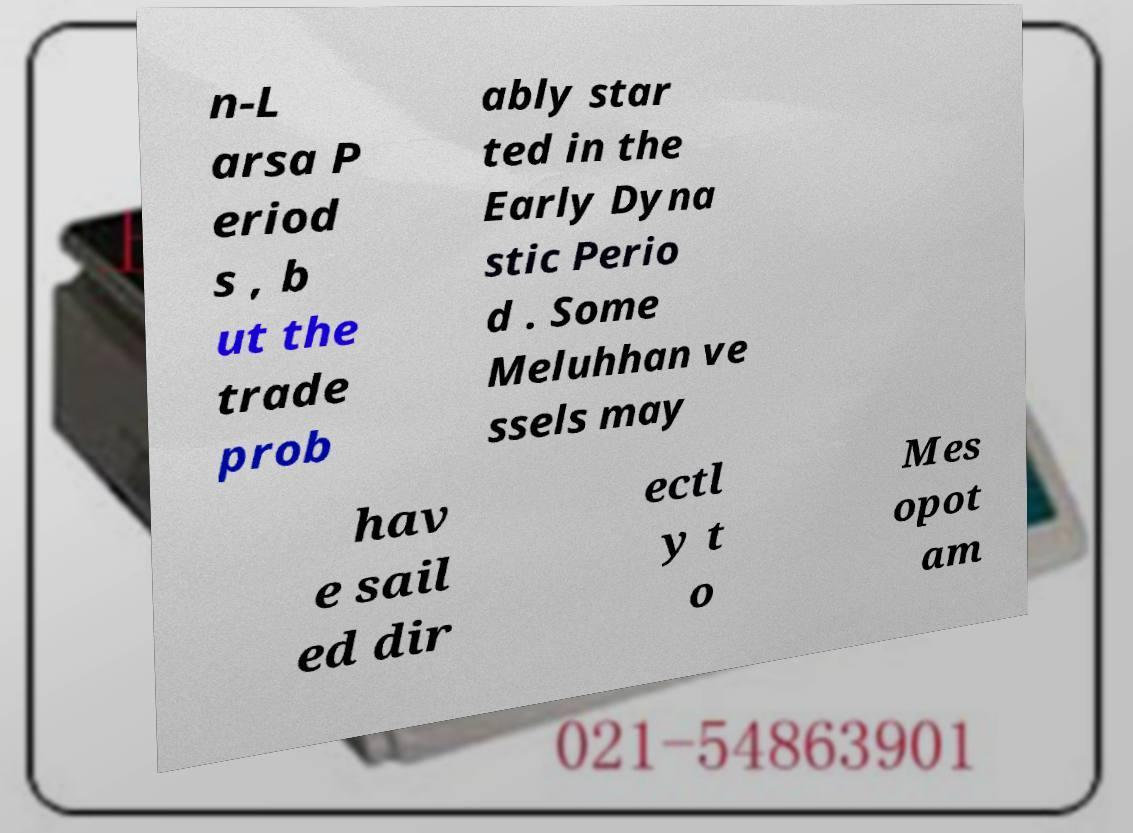Could you assist in decoding the text presented in this image and type it out clearly? n-L arsa P eriod s , b ut the trade prob ably star ted in the Early Dyna stic Perio d . Some Meluhhan ve ssels may hav e sail ed dir ectl y t o Mes opot am 